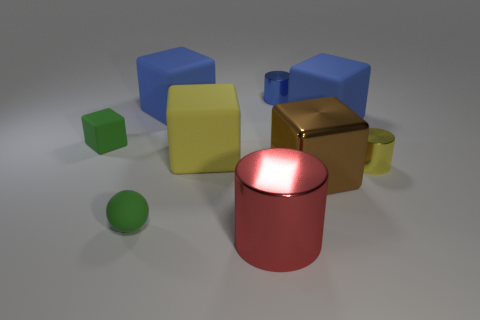Subtract 2 blocks. How many blocks are left? 3 Subtract all green cubes. How many cubes are left? 4 Subtract all small green rubber cubes. How many cubes are left? 4 Subtract all brown cubes. Subtract all yellow spheres. How many cubes are left? 4 Add 1 rubber balls. How many objects exist? 10 Subtract all cylinders. How many objects are left? 6 Add 5 blue cylinders. How many blue cylinders are left? 6 Add 2 metallic cubes. How many metallic cubes exist? 3 Subtract 0 red blocks. How many objects are left? 9 Subtract all big yellow balls. Subtract all tiny green cubes. How many objects are left? 8 